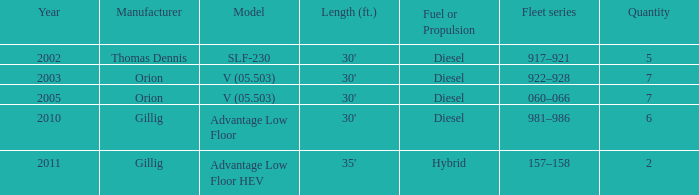What is the fleet series that comprises a total of five? 917–921. 